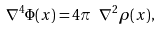<formula> <loc_0><loc_0><loc_500><loc_500>\nabla ^ { 4 } \Phi ( { x } ) = 4 \pi \ \nabla ^ { 2 } \rho ( { x } ) ,</formula> 